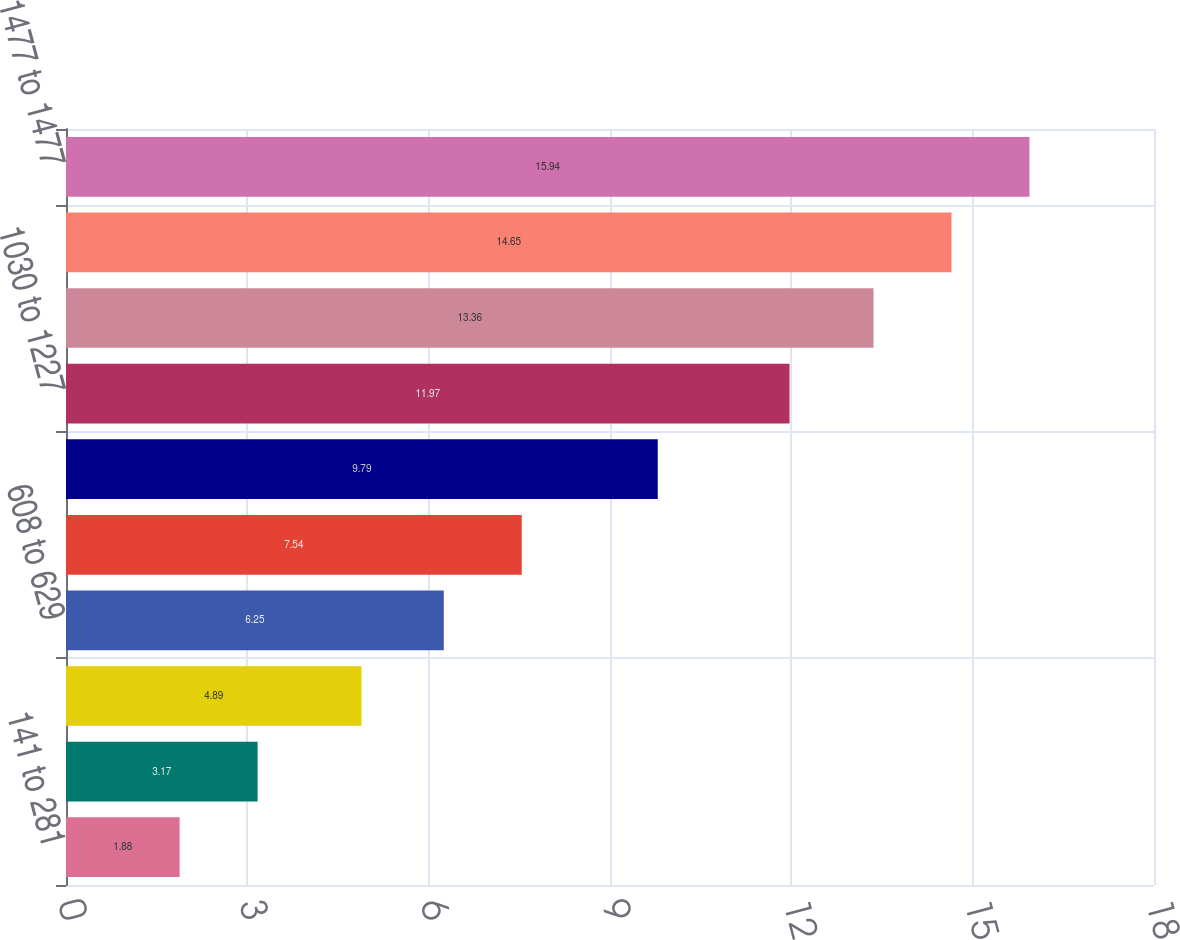Convert chart to OTSL. <chart><loc_0><loc_0><loc_500><loc_500><bar_chart><fcel>141 to 281<fcel>293 to 311<fcel>313 to 601<fcel>608 to 629<fcel>630 to 785<fcel>794 to 1020<fcel>1030 to 1227<fcel>1229 to 1423<fcel>1446 to 1446<fcel>1477 to 1477<nl><fcel>1.88<fcel>3.17<fcel>4.89<fcel>6.25<fcel>7.54<fcel>9.79<fcel>11.97<fcel>13.36<fcel>14.65<fcel>15.94<nl></chart> 